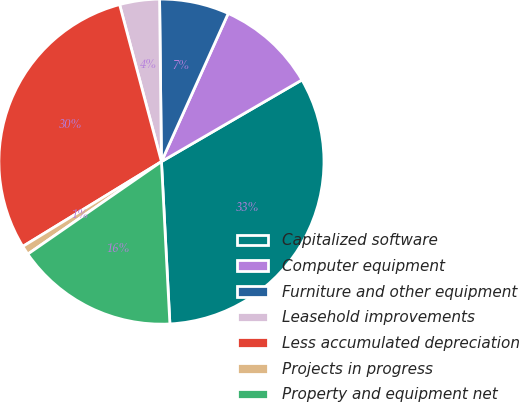Convert chart to OTSL. <chart><loc_0><loc_0><loc_500><loc_500><pie_chart><fcel>Capitalized software<fcel>Computer equipment<fcel>Furniture and other equipment<fcel>Leasehold improvements<fcel>Less accumulated depreciation<fcel>Projects in progress<fcel>Property and equipment net<nl><fcel>32.55%<fcel>9.88%<fcel>6.92%<fcel>3.96%<fcel>29.59%<fcel>0.9%<fcel>16.19%<nl></chart> 